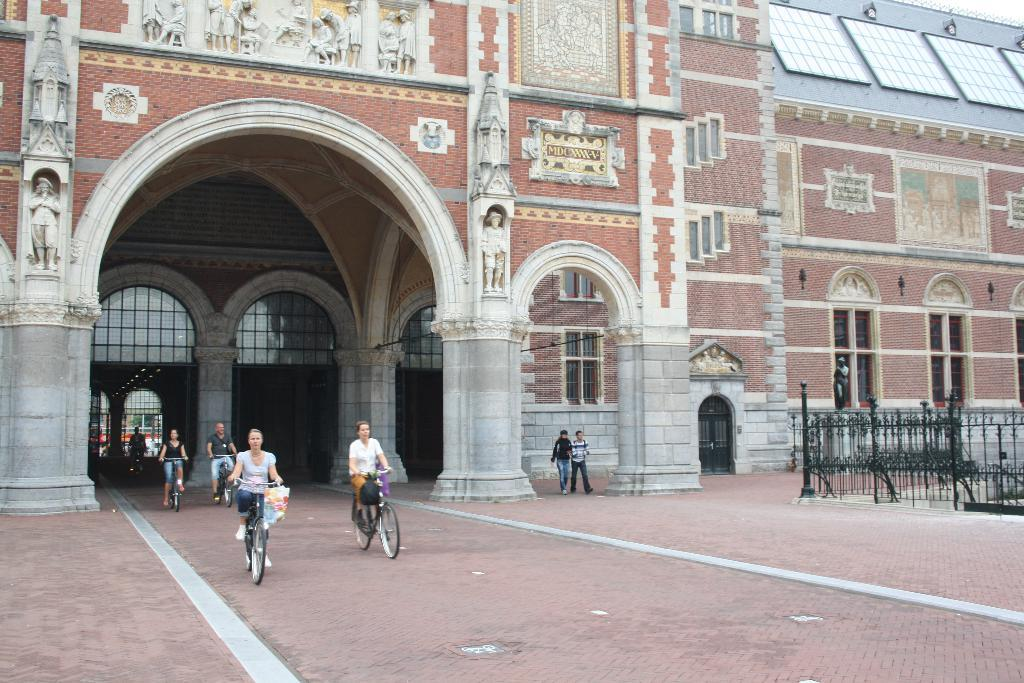How many people are riding bicycles in the image? There are five people riding bicycles in the image. What are two other activities being performed by people in the image? Two people are walking in the image. What type of structures can be seen in the image? There are statues and a building with windows in the image. What architectural feature is present in the image? There is a fence in the image. Can you describe any other objects in the image? There are some unspecified objects in the image. What type of soup is being served in the image? There is no soup present in the image. Can you describe the wheels on the bicycles in the image? The bicycles in the image have wheels, but the specific type or design of the wheels is not mentioned in the provided facts. 